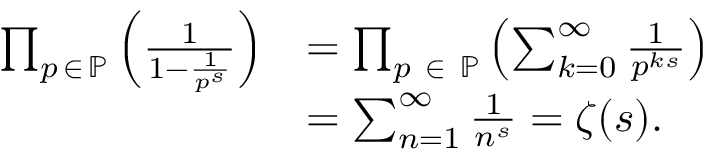Convert formula to latex. <formula><loc_0><loc_0><loc_500><loc_500>{ \begin{array} { r l } { \prod _ { p \, \in \, \mathbb { P } } \left ( { \frac { 1 } { 1 - { \frac { 1 } { p ^ { s } } } } } \right ) } & { = \prod _ { p \ \in \ \mathbb { P } } \left ( \sum _ { k = 0 } ^ { \infty } { \frac { 1 } { p ^ { k s } } } \right ) } \\ & { = \sum _ { n = 1 } ^ { \infty } { \frac { 1 } { n ^ { s } } } = \zeta ( s ) . } \end{array} }</formula> 